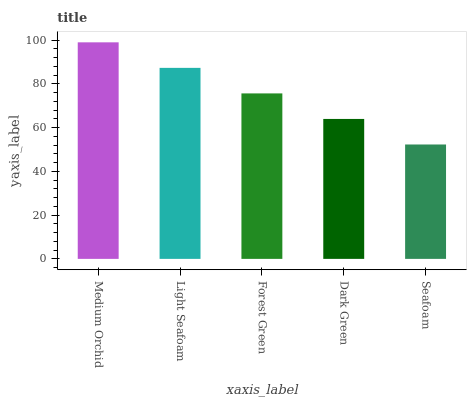Is Seafoam the minimum?
Answer yes or no. Yes. Is Medium Orchid the maximum?
Answer yes or no. Yes. Is Light Seafoam the minimum?
Answer yes or no. No. Is Light Seafoam the maximum?
Answer yes or no. No. Is Medium Orchid greater than Light Seafoam?
Answer yes or no. Yes. Is Light Seafoam less than Medium Orchid?
Answer yes or no. Yes. Is Light Seafoam greater than Medium Orchid?
Answer yes or no. No. Is Medium Orchid less than Light Seafoam?
Answer yes or no. No. Is Forest Green the high median?
Answer yes or no. Yes. Is Forest Green the low median?
Answer yes or no. Yes. Is Light Seafoam the high median?
Answer yes or no. No. Is Medium Orchid the low median?
Answer yes or no. No. 